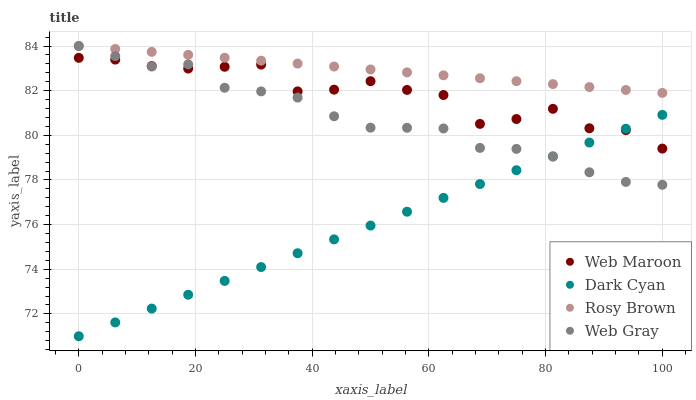Does Dark Cyan have the minimum area under the curve?
Answer yes or no. Yes. Does Rosy Brown have the maximum area under the curve?
Answer yes or no. Yes. Does Web Maroon have the minimum area under the curve?
Answer yes or no. No. Does Web Maroon have the maximum area under the curve?
Answer yes or no. No. Is Rosy Brown the smoothest?
Answer yes or no. Yes. Is Web Maroon the roughest?
Answer yes or no. Yes. Is Web Maroon the smoothest?
Answer yes or no. No. Is Rosy Brown the roughest?
Answer yes or no. No. Does Dark Cyan have the lowest value?
Answer yes or no. Yes. Does Web Maroon have the lowest value?
Answer yes or no. No. Does Web Gray have the highest value?
Answer yes or no. Yes. Does Web Maroon have the highest value?
Answer yes or no. No. Is Web Maroon less than Rosy Brown?
Answer yes or no. Yes. Is Rosy Brown greater than Web Maroon?
Answer yes or no. Yes. Does Web Gray intersect Web Maroon?
Answer yes or no. Yes. Is Web Gray less than Web Maroon?
Answer yes or no. No. Is Web Gray greater than Web Maroon?
Answer yes or no. No. Does Web Maroon intersect Rosy Brown?
Answer yes or no. No. 